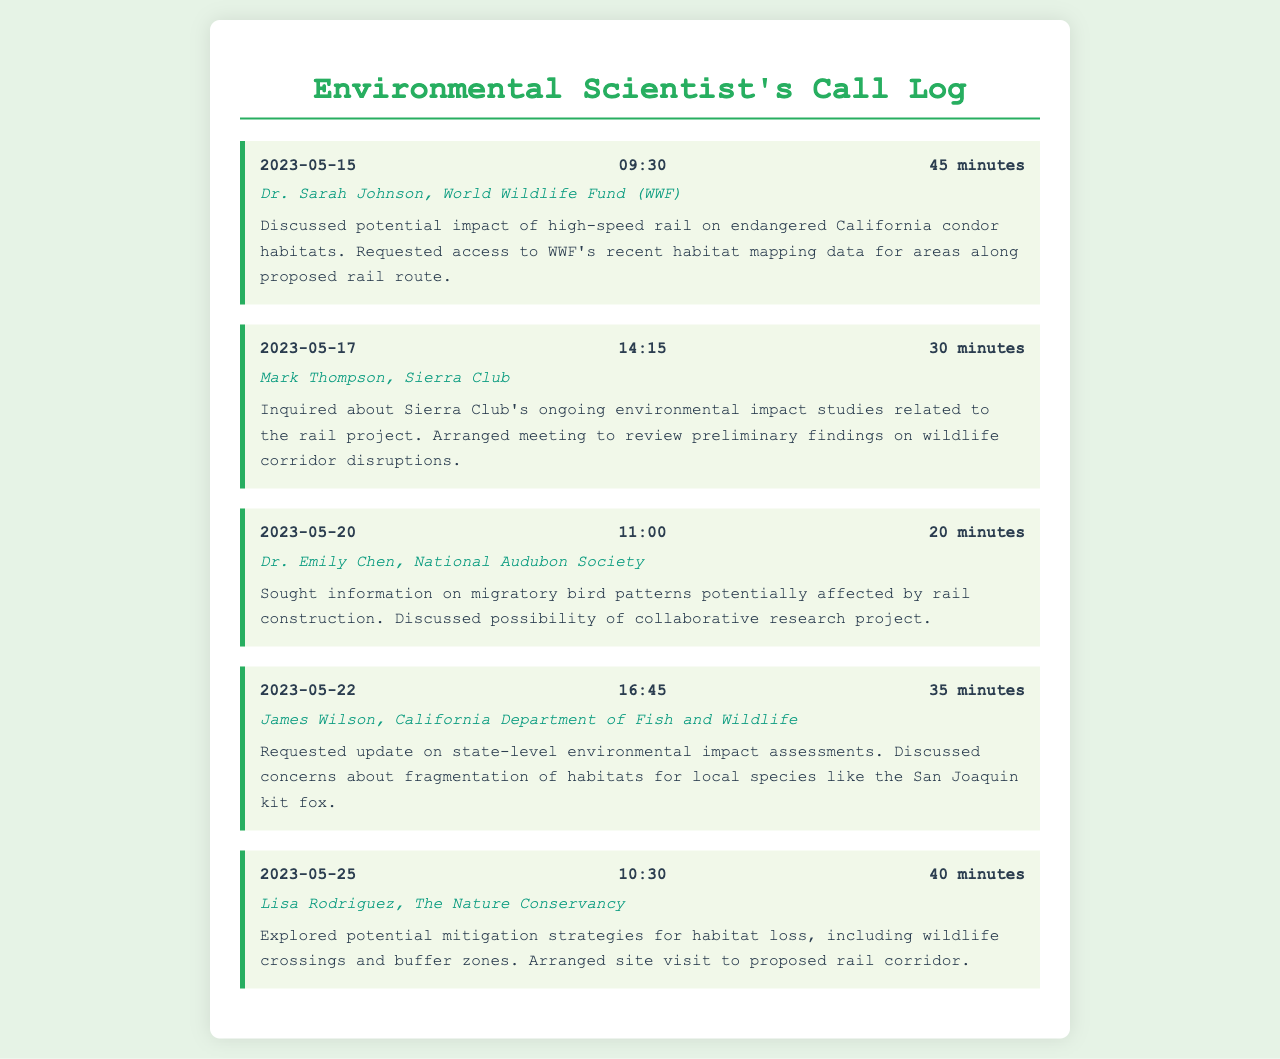What is the date of the first call? The first call is logged on May 15, 2023.
Answer: May 15, 2023 Who did the environmental scientist speak with on May 20, 2023? On May 20, 2023, the scientist spoke with Dr. Emily Chen from the National Audubon Society.
Answer: Dr. Emily Chen, National Audubon Society What was the duration of the call with Mark Thompson? The duration of the call with Mark Thompson was 30 minutes.
Answer: 30 minutes Which wildlife species was discussed during the call with James Wilson? During the call with James Wilson, the San Joaquin kit fox was discussed.
Answer: San Joaquin kit fox What topic was covered in the call on May 25, 2023? The call on May 25, 2023, covered potential mitigation strategies for habitat loss.
Answer: Mitigation strategies for habitat loss How many calls are documented in total? The total number of calls documented in the call log is five.
Answer: Five What did the scientist request during the call with Dr. Sarah Johnson? The scientist requested access to WWF's recent habitat mapping data.
Answer: Access to WWF's recent habitat mapping data What organization did Lisa Rodriguez represent? Lisa Rodriguez represented The Nature Conservancy.
Answer: The Nature Conservancy What is the primary concern discussed in the call with James Wilson? The primary concern discussed was the fragmentation of habitats.
Answer: Fragmentation of habitats 